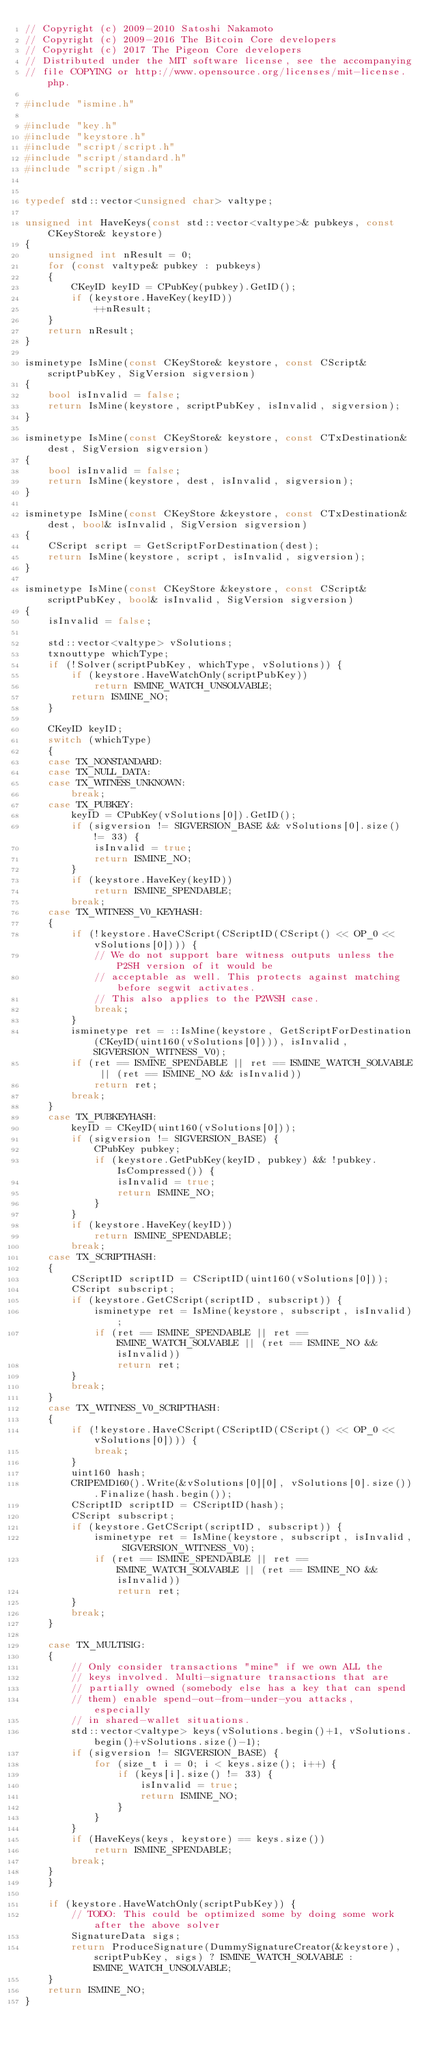<code> <loc_0><loc_0><loc_500><loc_500><_C++_>// Copyright (c) 2009-2010 Satoshi Nakamoto
// Copyright (c) 2009-2016 The Bitcoin Core developers
// Copyright (c) 2017 The Pigeon Core developers
// Distributed under the MIT software license, see the accompanying
// file COPYING or http://www.opensource.org/licenses/mit-license.php.

#include "ismine.h"

#include "key.h"
#include "keystore.h"
#include "script/script.h"
#include "script/standard.h"
#include "script/sign.h"


typedef std::vector<unsigned char> valtype;

unsigned int HaveKeys(const std::vector<valtype>& pubkeys, const CKeyStore& keystore)
{
    unsigned int nResult = 0;
    for (const valtype& pubkey : pubkeys)
    {
        CKeyID keyID = CPubKey(pubkey).GetID();
        if (keystore.HaveKey(keyID))
            ++nResult;
    }
    return nResult;
}

isminetype IsMine(const CKeyStore& keystore, const CScript& scriptPubKey, SigVersion sigversion)
{
    bool isInvalid = false;
    return IsMine(keystore, scriptPubKey, isInvalid, sigversion);
}

isminetype IsMine(const CKeyStore& keystore, const CTxDestination& dest, SigVersion sigversion)
{
    bool isInvalid = false;
    return IsMine(keystore, dest, isInvalid, sigversion);
}

isminetype IsMine(const CKeyStore &keystore, const CTxDestination& dest, bool& isInvalid, SigVersion sigversion)
{
    CScript script = GetScriptForDestination(dest);
    return IsMine(keystore, script, isInvalid, sigversion);
}

isminetype IsMine(const CKeyStore &keystore, const CScript& scriptPubKey, bool& isInvalid, SigVersion sigversion)
{
    isInvalid = false;

    std::vector<valtype> vSolutions;
    txnouttype whichType;
    if (!Solver(scriptPubKey, whichType, vSolutions)) {
        if (keystore.HaveWatchOnly(scriptPubKey))
            return ISMINE_WATCH_UNSOLVABLE;
        return ISMINE_NO;
    }

    CKeyID keyID;
    switch (whichType)
    {
    case TX_NONSTANDARD:
    case TX_NULL_DATA:
    case TX_WITNESS_UNKNOWN:
        break;
    case TX_PUBKEY:
        keyID = CPubKey(vSolutions[0]).GetID();
        if (sigversion != SIGVERSION_BASE && vSolutions[0].size() != 33) {
            isInvalid = true;
            return ISMINE_NO;
        }
        if (keystore.HaveKey(keyID))
            return ISMINE_SPENDABLE;
        break;
    case TX_WITNESS_V0_KEYHASH:
    {
        if (!keystore.HaveCScript(CScriptID(CScript() << OP_0 << vSolutions[0]))) {
            // We do not support bare witness outputs unless the P2SH version of it would be
            // acceptable as well. This protects against matching before segwit activates.
            // This also applies to the P2WSH case.
            break;
        }
        isminetype ret = ::IsMine(keystore, GetScriptForDestination(CKeyID(uint160(vSolutions[0]))), isInvalid, SIGVERSION_WITNESS_V0);
        if (ret == ISMINE_SPENDABLE || ret == ISMINE_WATCH_SOLVABLE || (ret == ISMINE_NO && isInvalid))
            return ret;
        break;
    }
    case TX_PUBKEYHASH:
        keyID = CKeyID(uint160(vSolutions[0]));
        if (sigversion != SIGVERSION_BASE) {
            CPubKey pubkey;
            if (keystore.GetPubKey(keyID, pubkey) && !pubkey.IsCompressed()) {
                isInvalid = true;
                return ISMINE_NO;
            }
        }
        if (keystore.HaveKey(keyID))
            return ISMINE_SPENDABLE;
        break;
    case TX_SCRIPTHASH:
    {
        CScriptID scriptID = CScriptID(uint160(vSolutions[0]));
        CScript subscript;
        if (keystore.GetCScript(scriptID, subscript)) {
            isminetype ret = IsMine(keystore, subscript, isInvalid);
            if (ret == ISMINE_SPENDABLE || ret == ISMINE_WATCH_SOLVABLE || (ret == ISMINE_NO && isInvalid))
                return ret;
        }
        break;
    }
    case TX_WITNESS_V0_SCRIPTHASH:
    {
        if (!keystore.HaveCScript(CScriptID(CScript() << OP_0 << vSolutions[0]))) {
            break;
        }
        uint160 hash;
        CRIPEMD160().Write(&vSolutions[0][0], vSolutions[0].size()).Finalize(hash.begin());
        CScriptID scriptID = CScriptID(hash);
        CScript subscript;
        if (keystore.GetCScript(scriptID, subscript)) {
            isminetype ret = IsMine(keystore, subscript, isInvalid, SIGVERSION_WITNESS_V0);
            if (ret == ISMINE_SPENDABLE || ret == ISMINE_WATCH_SOLVABLE || (ret == ISMINE_NO && isInvalid))
                return ret;
        }
        break;
    }

    case TX_MULTISIG:
    {
        // Only consider transactions "mine" if we own ALL the
        // keys involved. Multi-signature transactions that are
        // partially owned (somebody else has a key that can spend
        // them) enable spend-out-from-under-you attacks, especially
        // in shared-wallet situations.
        std::vector<valtype> keys(vSolutions.begin()+1, vSolutions.begin()+vSolutions.size()-1);
        if (sigversion != SIGVERSION_BASE) {
            for (size_t i = 0; i < keys.size(); i++) {
                if (keys[i].size() != 33) {
                    isInvalid = true;
                    return ISMINE_NO;
                }
            }
        }
        if (HaveKeys(keys, keystore) == keys.size())
            return ISMINE_SPENDABLE;
        break;
    }
    }

    if (keystore.HaveWatchOnly(scriptPubKey)) {
        // TODO: This could be optimized some by doing some work after the above solver
        SignatureData sigs;
        return ProduceSignature(DummySignatureCreator(&keystore), scriptPubKey, sigs) ? ISMINE_WATCH_SOLVABLE : ISMINE_WATCH_UNSOLVABLE;
    }
    return ISMINE_NO;
}
</code> 